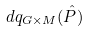<formula> <loc_0><loc_0><loc_500><loc_500>d q _ { G \times M } ( \hat { P } )</formula> 